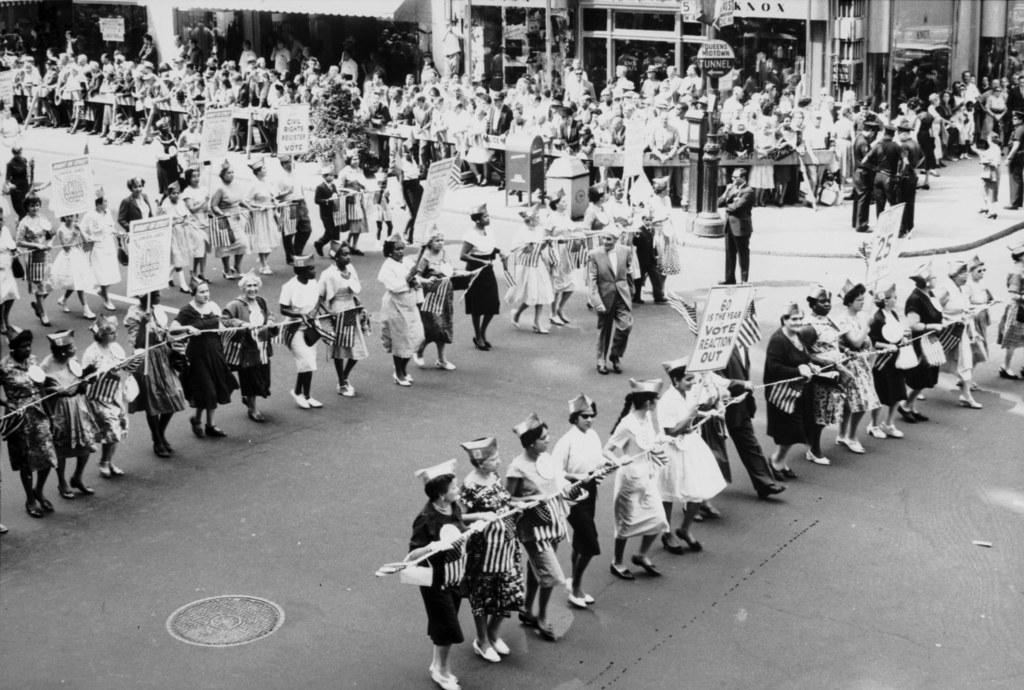What is the color scheme of the image? The image is black and white. What are the people in the image doing? The people in the image are holding objects, including boards. What type of establishments can be seen in the image? There are stores visible in the image. How many fingers can be seen writing on the board in the image? There is no writing or fingers visible on the boards in the image. What type of copy is being made by the people in the image? There is no copying activity depicted in the image; people are holding boards. 